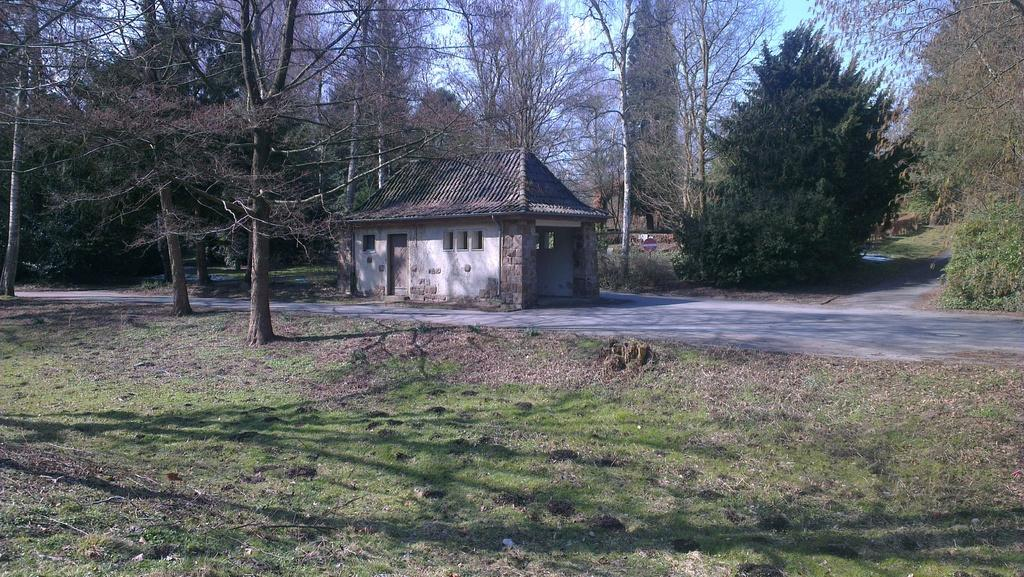What type of structure is present in the image? There is a house in the image. Can you describe the house's features? The house has a roof, windows, and a door. What can be seen in the foreground of the image? There is grass visible in the image. What type of vegetation is present in the background of the image? There is a group of trees in the image. What is the pathway used for in the image? The pathway is likely used for walking or accessing the house. What is the condition of the sky in the image? The sky is visible in the image and appears cloudy. What type of treatment is the laborer receiving in the image? There is no laborer present in the image, and therefore no treatment can be observed. 